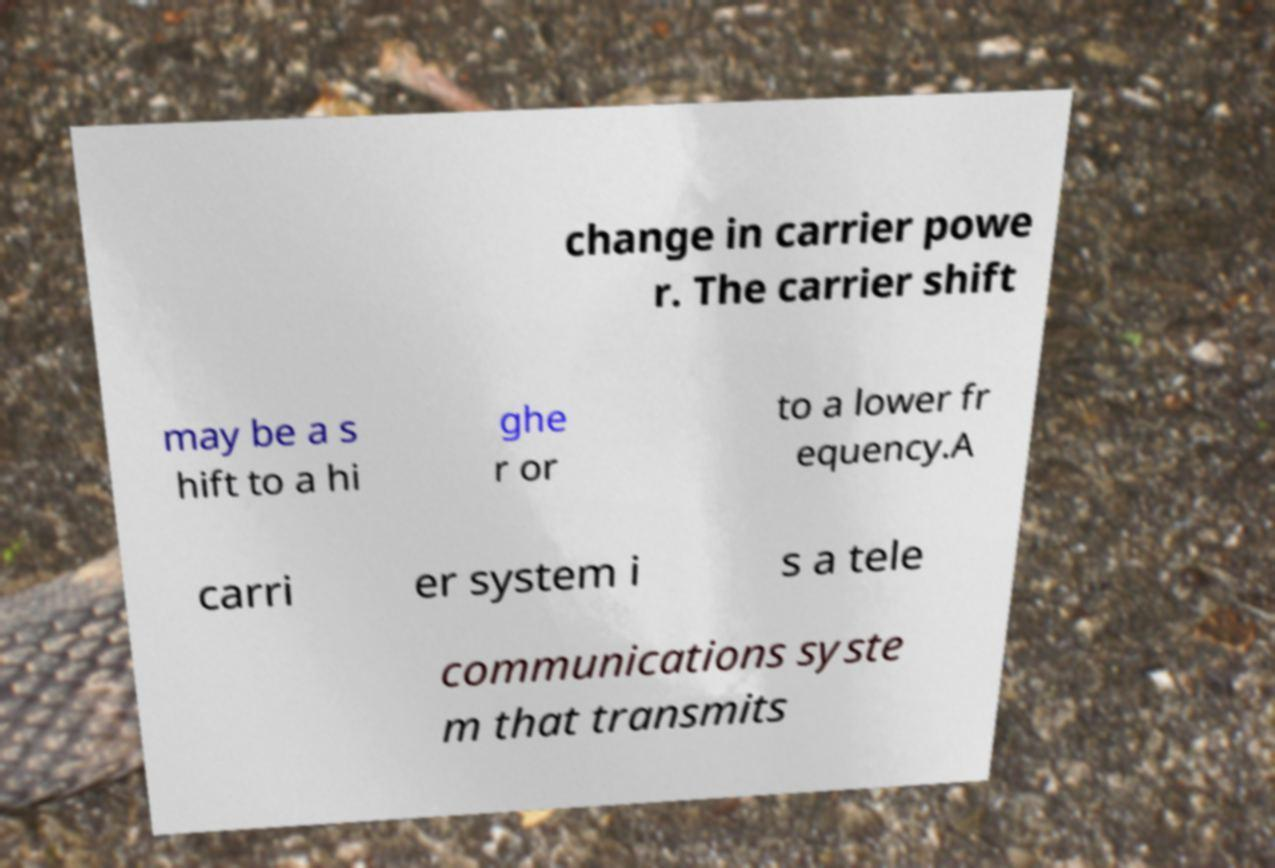I need the written content from this picture converted into text. Can you do that? change in carrier powe r. The carrier shift may be a s hift to a hi ghe r or to a lower fr equency.A carri er system i s a tele communications syste m that transmits 